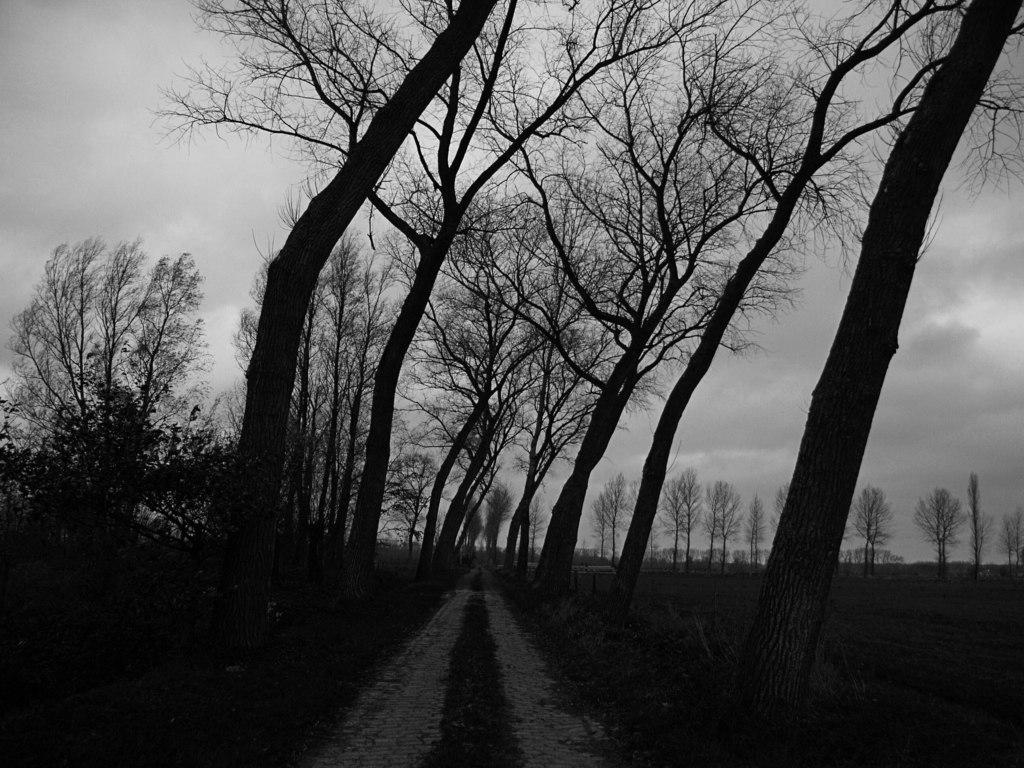What is the color scheme of the image? The image is black and white. What can be seen in the image among the trees? There are tree branches in the image. What is the path used for in the image? The path is visible in the image. What type of vegetation is present in the image? There is grass in the image. What is the condition of the sky in the image? The sky is cloudy in the image. What type of bottle is hidden among the tree branches in the image? There is no bottle present in the image; it only features tree branches, a path, grass, and a cloudy sky. 